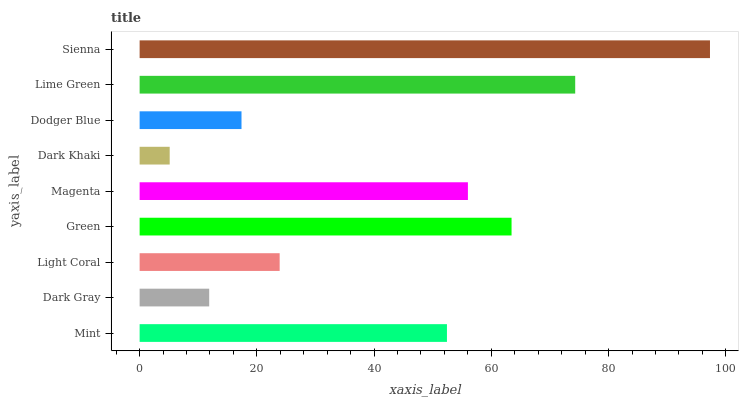Is Dark Khaki the minimum?
Answer yes or no. Yes. Is Sienna the maximum?
Answer yes or no. Yes. Is Dark Gray the minimum?
Answer yes or no. No. Is Dark Gray the maximum?
Answer yes or no. No. Is Mint greater than Dark Gray?
Answer yes or no. Yes. Is Dark Gray less than Mint?
Answer yes or no. Yes. Is Dark Gray greater than Mint?
Answer yes or no. No. Is Mint less than Dark Gray?
Answer yes or no. No. Is Mint the high median?
Answer yes or no. Yes. Is Mint the low median?
Answer yes or no. Yes. Is Green the high median?
Answer yes or no. No. Is Dark Khaki the low median?
Answer yes or no. No. 